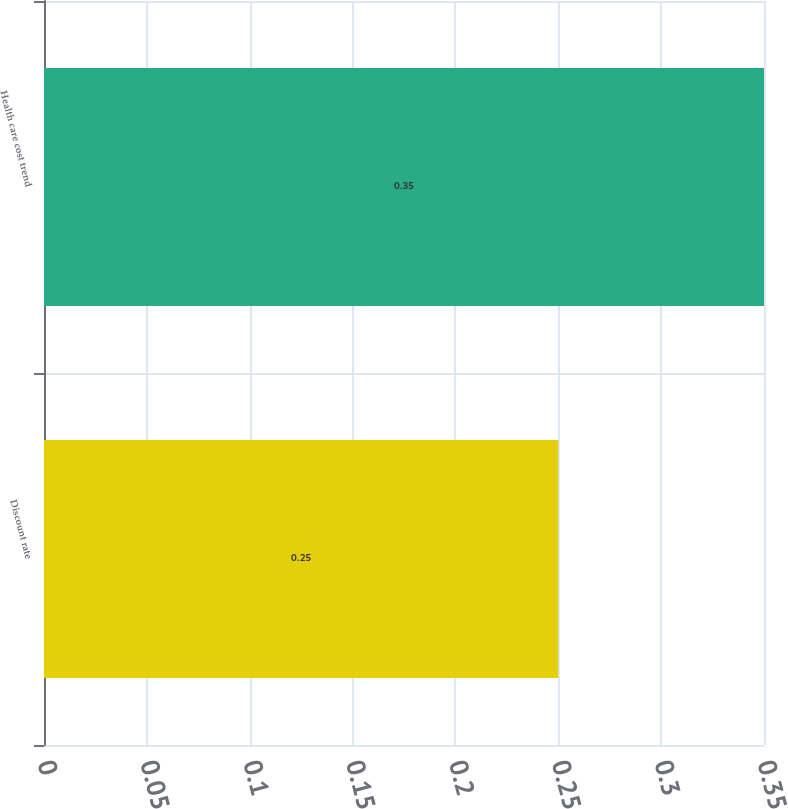Convert chart. <chart><loc_0><loc_0><loc_500><loc_500><bar_chart><fcel>Discount rate<fcel>Health care cost trend<nl><fcel>0.25<fcel>0.35<nl></chart> 